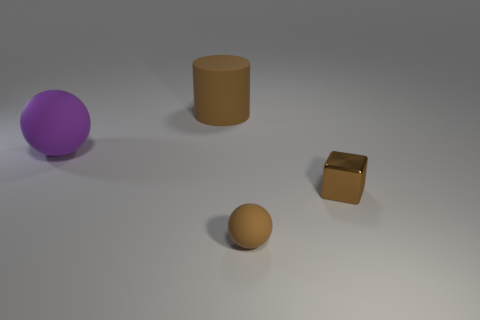Add 3 big purple metal cubes. How many objects exist? 7 Subtract all blocks. How many objects are left? 3 Subtract 0 green spheres. How many objects are left? 4 Subtract all small matte balls. Subtract all shiny cubes. How many objects are left? 2 Add 2 metallic things. How many metallic things are left? 3 Add 1 tiny metallic objects. How many tiny metallic objects exist? 2 